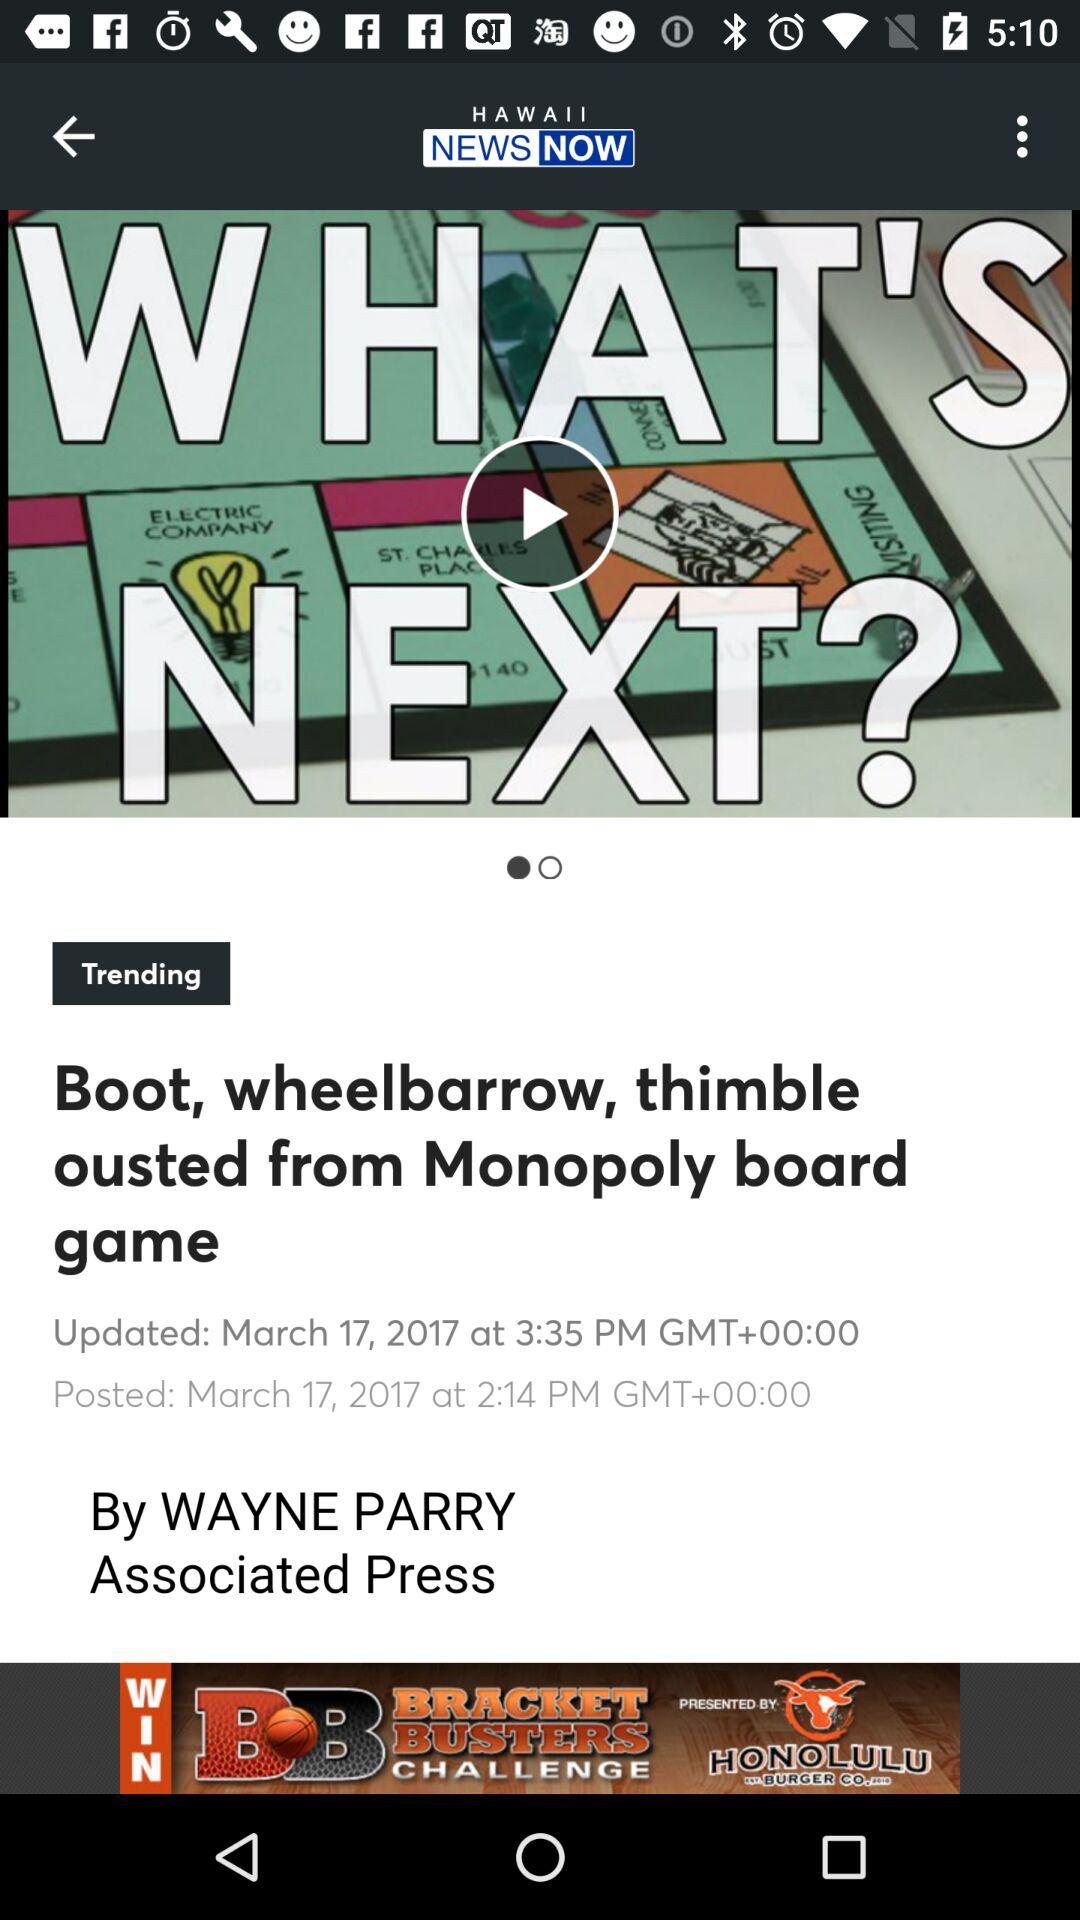What is the updated date? The updated date is March 17, 2017. 